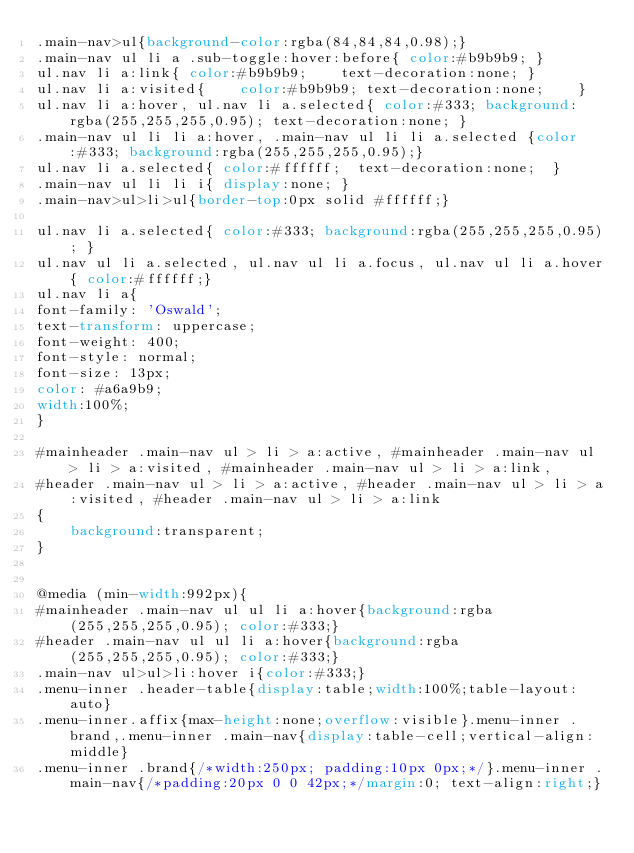<code> <loc_0><loc_0><loc_500><loc_500><_CSS_>.main-nav>ul{background-color:rgba(84,84,84,0.98);}
.main-nav ul li a .sub-toggle:hover:before{ color:#b9b9b9; }
ul.nav li a:link{ color:#b9b9b9;	text-decoration:none; }
ul.nav li a:visited{	color:#b9b9b9; text-decoration:none; 	}
ul.nav li a:hover, ul.nav li a.selected{ color:#333; background:rgba(255,255,255,0.95); text-decoration:none; }
.main-nav ul li li a:hover, .main-nav ul li li a.selected {color:#333; background:rgba(255,255,255,0.95);}
ul.nav li a.selected{ color:#ffffff;  text-decoration:none;  }
.main-nav ul li li i{ display:none; }
.main-nav>ul>li>ul{border-top:0px solid #ffffff;}

ul.nav li a.selected{ color:#333; background:rgba(255,255,255,0.95); } 
ul.nav ul li a.selected, ul.nav ul li a.focus, ul.nav ul li a.hover{ color:#ffffff;}
ul.nav li a{
font-family: 'Oswald';
text-transform: uppercase;
font-weight: 400;
font-style: normal;
font-size: 13px;
color: #a6a9b9;
width:100%;
}

#mainheader .main-nav ul > li > a:active, #mainheader .main-nav ul > li > a:visited, #mainheader .main-nav ul > li > a:link,
#header .main-nav ul > li > a:active, #header .main-nav ul > li > a:visited, #header .main-nav ul > li > a:link
{
	background:transparent;
}


@media (min-width:992px){
#mainheader .main-nav ul ul li a:hover{background:rgba(255,255,255,0.95); color:#333;}
#header .main-nav ul ul li a:hover{background:rgba(255,255,255,0.95); color:#333;}
.main-nav ul>ul>li:hover i{color:#333;}
.menu-inner .header-table{display:table;width:100%;table-layout:auto}
.menu-inner.affix{max-height:none;overflow:visible}.menu-inner .brand,.menu-inner .main-nav{display:table-cell;vertical-align:middle}
.menu-inner .brand{/*width:250px; padding:10px 0px;*/}.menu-inner .main-nav{/*padding:20px 0 0 42px;*/margin:0; text-align:right;}</code> 